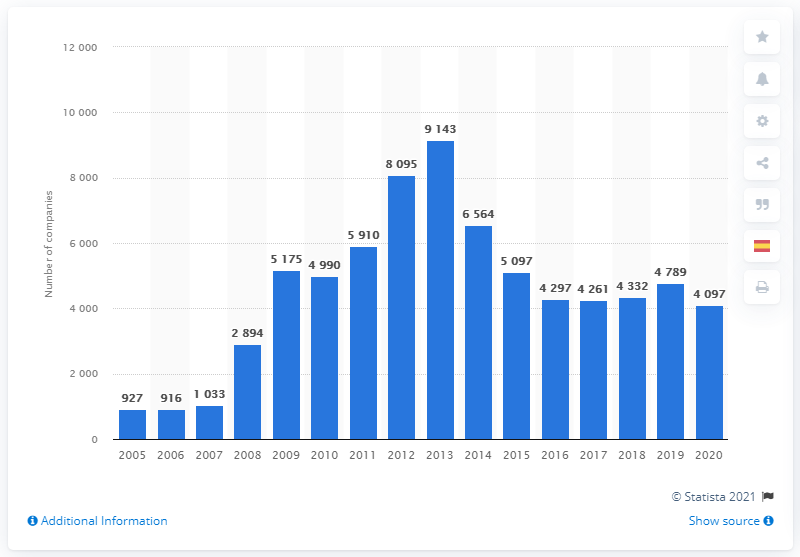Are there any anomalies or outliers in the data presented? Based on the bar graph, there aren't any extreme outliers, but 2009 stands out as the year with the highest number of bankruptcies, which suggests it is an anomaly related to the economic conditions of the time. The relatively steady decline afterwards suggests that 2009 was a peak year for bankruptcies within this period.  What might be the reasons for the peak in bankruptcies in 2009? The peak in bankruptcies in 2009 can generally be attributed to the global financial crisis that began in 2007-2008, which led to a severe economic downturn. Many businesses faced reduced consumer spending, credit crunches, and overall financial instability, which contributed to the increased number of bankruptcies in 2009. 